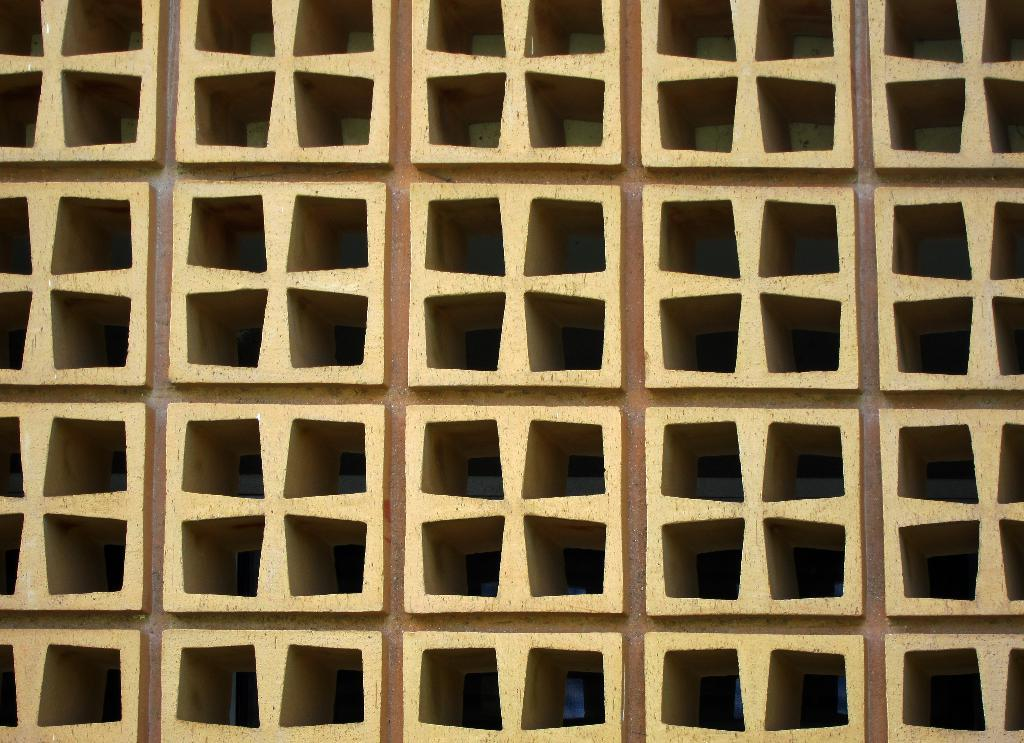What can be seen in the image? There is an object in the image. Can you describe the appearance of the object? The object has a brown and cream color. What type of insurance is being discussed in the image? There is no mention of insurance in the image, as the facts only describe an object with a brown and cream color. 